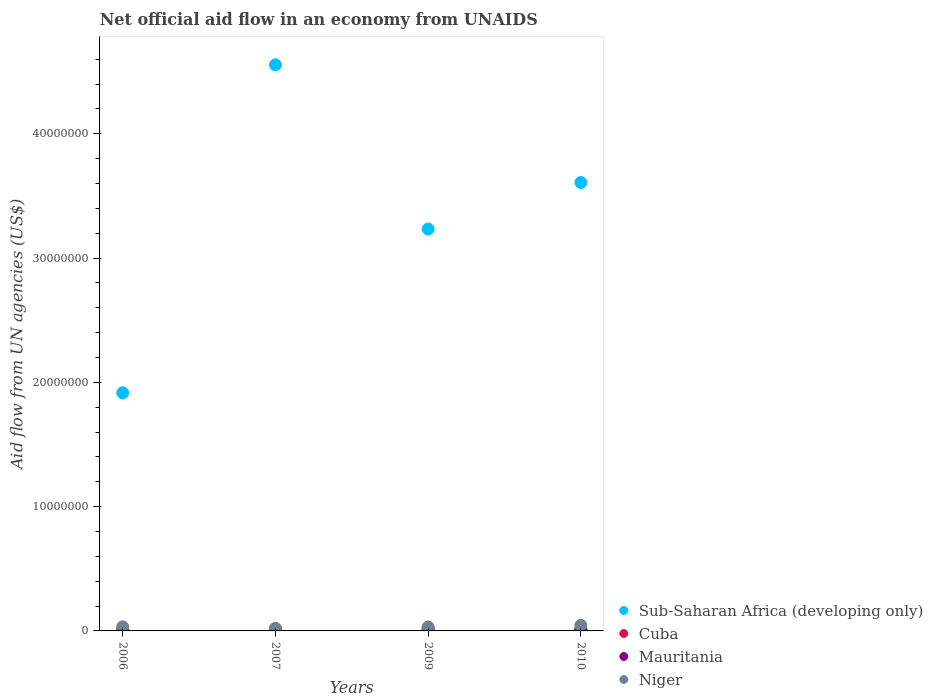How many different coloured dotlines are there?
Your response must be concise. 4. Is the number of dotlines equal to the number of legend labels?
Keep it short and to the point. Yes. What is the net official aid flow in Niger in 2009?
Make the answer very short. 3.20e+05. Across all years, what is the maximum net official aid flow in Sub-Saharan Africa (developing only)?
Provide a succinct answer. 4.56e+07. Across all years, what is the minimum net official aid flow in Mauritania?
Ensure brevity in your answer.  6.00e+04. In which year was the net official aid flow in Sub-Saharan Africa (developing only) minimum?
Give a very brief answer. 2006. What is the total net official aid flow in Mauritania in the graph?
Keep it short and to the point. 5.90e+05. What is the difference between the net official aid flow in Niger in 2007 and that in 2010?
Give a very brief answer. -2.60e+05. What is the difference between the net official aid flow in Mauritania in 2006 and the net official aid flow in Niger in 2010?
Provide a succinct answer. -3.90e+05. What is the average net official aid flow in Mauritania per year?
Keep it short and to the point. 1.48e+05. In the year 2006, what is the difference between the net official aid flow in Sub-Saharan Africa (developing only) and net official aid flow in Mauritania?
Your answer should be very brief. 1.91e+07. In how many years, is the net official aid flow in Cuba greater than 4000000 US$?
Offer a terse response. 0. What is the ratio of the net official aid flow in Sub-Saharan Africa (developing only) in 2006 to that in 2010?
Give a very brief answer. 0.53. Is the sum of the net official aid flow in Niger in 2009 and 2010 greater than the maximum net official aid flow in Cuba across all years?
Keep it short and to the point. Yes. Is it the case that in every year, the sum of the net official aid flow in Cuba and net official aid flow in Niger  is greater than the sum of net official aid flow in Mauritania and net official aid flow in Sub-Saharan Africa (developing only)?
Give a very brief answer. Yes. Is it the case that in every year, the sum of the net official aid flow in Mauritania and net official aid flow in Niger  is greater than the net official aid flow in Cuba?
Provide a short and direct response. Yes. Does the net official aid flow in Niger monotonically increase over the years?
Keep it short and to the point. No. Is the net official aid flow in Mauritania strictly greater than the net official aid flow in Niger over the years?
Provide a short and direct response. No. How many dotlines are there?
Your answer should be very brief. 4. Does the graph contain any zero values?
Your response must be concise. No. Where does the legend appear in the graph?
Give a very brief answer. Bottom right. How are the legend labels stacked?
Provide a succinct answer. Vertical. What is the title of the graph?
Give a very brief answer. Net official aid flow in an economy from UNAIDS. Does "Timor-Leste" appear as one of the legend labels in the graph?
Your answer should be very brief. No. What is the label or title of the X-axis?
Offer a very short reply. Years. What is the label or title of the Y-axis?
Provide a short and direct response. Aid flow from UN agencies (US$). What is the Aid flow from UN agencies (US$) in Sub-Saharan Africa (developing only) in 2006?
Offer a very short reply. 1.92e+07. What is the Aid flow from UN agencies (US$) in Mauritania in 2006?
Your answer should be very brief. 6.00e+04. What is the Aid flow from UN agencies (US$) of Sub-Saharan Africa (developing only) in 2007?
Ensure brevity in your answer.  4.56e+07. What is the Aid flow from UN agencies (US$) in Cuba in 2007?
Give a very brief answer. 1.60e+05. What is the Aid flow from UN agencies (US$) of Mauritania in 2007?
Your response must be concise. 1.90e+05. What is the Aid flow from UN agencies (US$) of Sub-Saharan Africa (developing only) in 2009?
Offer a very short reply. 3.23e+07. What is the Aid flow from UN agencies (US$) in Mauritania in 2009?
Keep it short and to the point. 2.10e+05. What is the Aid flow from UN agencies (US$) in Sub-Saharan Africa (developing only) in 2010?
Offer a terse response. 3.61e+07. What is the Aid flow from UN agencies (US$) of Cuba in 2010?
Your response must be concise. 1.00e+05. Across all years, what is the maximum Aid flow from UN agencies (US$) of Sub-Saharan Africa (developing only)?
Your response must be concise. 4.56e+07. Across all years, what is the maximum Aid flow from UN agencies (US$) of Mauritania?
Make the answer very short. 2.10e+05. Across all years, what is the maximum Aid flow from UN agencies (US$) of Niger?
Your response must be concise. 4.50e+05. Across all years, what is the minimum Aid flow from UN agencies (US$) in Sub-Saharan Africa (developing only)?
Your answer should be compact. 1.92e+07. Across all years, what is the minimum Aid flow from UN agencies (US$) in Niger?
Offer a very short reply. 1.90e+05. What is the total Aid flow from UN agencies (US$) in Sub-Saharan Africa (developing only) in the graph?
Give a very brief answer. 1.33e+08. What is the total Aid flow from UN agencies (US$) of Mauritania in the graph?
Keep it short and to the point. 5.90e+05. What is the total Aid flow from UN agencies (US$) of Niger in the graph?
Provide a succinct answer. 1.29e+06. What is the difference between the Aid flow from UN agencies (US$) in Sub-Saharan Africa (developing only) in 2006 and that in 2007?
Your answer should be compact. -2.64e+07. What is the difference between the Aid flow from UN agencies (US$) of Cuba in 2006 and that in 2007?
Your response must be concise. -5.00e+04. What is the difference between the Aid flow from UN agencies (US$) in Sub-Saharan Africa (developing only) in 2006 and that in 2009?
Provide a succinct answer. -1.32e+07. What is the difference between the Aid flow from UN agencies (US$) in Niger in 2006 and that in 2009?
Your answer should be compact. 10000. What is the difference between the Aid flow from UN agencies (US$) in Sub-Saharan Africa (developing only) in 2006 and that in 2010?
Give a very brief answer. -1.69e+07. What is the difference between the Aid flow from UN agencies (US$) of Niger in 2006 and that in 2010?
Make the answer very short. -1.20e+05. What is the difference between the Aid flow from UN agencies (US$) in Sub-Saharan Africa (developing only) in 2007 and that in 2009?
Your answer should be compact. 1.32e+07. What is the difference between the Aid flow from UN agencies (US$) in Cuba in 2007 and that in 2009?
Provide a succinct answer. 6.00e+04. What is the difference between the Aid flow from UN agencies (US$) of Mauritania in 2007 and that in 2009?
Your response must be concise. -2.00e+04. What is the difference between the Aid flow from UN agencies (US$) of Niger in 2007 and that in 2009?
Give a very brief answer. -1.30e+05. What is the difference between the Aid flow from UN agencies (US$) of Sub-Saharan Africa (developing only) in 2007 and that in 2010?
Your answer should be very brief. 9.47e+06. What is the difference between the Aid flow from UN agencies (US$) of Cuba in 2007 and that in 2010?
Your answer should be very brief. 6.00e+04. What is the difference between the Aid flow from UN agencies (US$) of Sub-Saharan Africa (developing only) in 2009 and that in 2010?
Provide a succinct answer. -3.74e+06. What is the difference between the Aid flow from UN agencies (US$) of Niger in 2009 and that in 2010?
Ensure brevity in your answer.  -1.30e+05. What is the difference between the Aid flow from UN agencies (US$) in Sub-Saharan Africa (developing only) in 2006 and the Aid flow from UN agencies (US$) in Cuba in 2007?
Keep it short and to the point. 1.90e+07. What is the difference between the Aid flow from UN agencies (US$) of Sub-Saharan Africa (developing only) in 2006 and the Aid flow from UN agencies (US$) of Mauritania in 2007?
Your answer should be very brief. 1.90e+07. What is the difference between the Aid flow from UN agencies (US$) in Sub-Saharan Africa (developing only) in 2006 and the Aid flow from UN agencies (US$) in Niger in 2007?
Your answer should be compact. 1.90e+07. What is the difference between the Aid flow from UN agencies (US$) of Cuba in 2006 and the Aid flow from UN agencies (US$) of Niger in 2007?
Your answer should be compact. -8.00e+04. What is the difference between the Aid flow from UN agencies (US$) in Sub-Saharan Africa (developing only) in 2006 and the Aid flow from UN agencies (US$) in Cuba in 2009?
Your response must be concise. 1.91e+07. What is the difference between the Aid flow from UN agencies (US$) of Sub-Saharan Africa (developing only) in 2006 and the Aid flow from UN agencies (US$) of Mauritania in 2009?
Keep it short and to the point. 1.90e+07. What is the difference between the Aid flow from UN agencies (US$) in Sub-Saharan Africa (developing only) in 2006 and the Aid flow from UN agencies (US$) in Niger in 2009?
Offer a very short reply. 1.88e+07. What is the difference between the Aid flow from UN agencies (US$) of Mauritania in 2006 and the Aid flow from UN agencies (US$) of Niger in 2009?
Offer a very short reply. -2.60e+05. What is the difference between the Aid flow from UN agencies (US$) in Sub-Saharan Africa (developing only) in 2006 and the Aid flow from UN agencies (US$) in Cuba in 2010?
Give a very brief answer. 1.91e+07. What is the difference between the Aid flow from UN agencies (US$) in Sub-Saharan Africa (developing only) in 2006 and the Aid flow from UN agencies (US$) in Mauritania in 2010?
Offer a terse response. 1.90e+07. What is the difference between the Aid flow from UN agencies (US$) of Sub-Saharan Africa (developing only) in 2006 and the Aid flow from UN agencies (US$) of Niger in 2010?
Provide a succinct answer. 1.87e+07. What is the difference between the Aid flow from UN agencies (US$) of Cuba in 2006 and the Aid flow from UN agencies (US$) of Mauritania in 2010?
Ensure brevity in your answer.  -2.00e+04. What is the difference between the Aid flow from UN agencies (US$) in Cuba in 2006 and the Aid flow from UN agencies (US$) in Niger in 2010?
Offer a terse response. -3.40e+05. What is the difference between the Aid flow from UN agencies (US$) of Mauritania in 2006 and the Aid flow from UN agencies (US$) of Niger in 2010?
Offer a very short reply. -3.90e+05. What is the difference between the Aid flow from UN agencies (US$) of Sub-Saharan Africa (developing only) in 2007 and the Aid flow from UN agencies (US$) of Cuba in 2009?
Your answer should be compact. 4.54e+07. What is the difference between the Aid flow from UN agencies (US$) of Sub-Saharan Africa (developing only) in 2007 and the Aid flow from UN agencies (US$) of Mauritania in 2009?
Make the answer very short. 4.53e+07. What is the difference between the Aid flow from UN agencies (US$) in Sub-Saharan Africa (developing only) in 2007 and the Aid flow from UN agencies (US$) in Niger in 2009?
Your answer should be very brief. 4.52e+07. What is the difference between the Aid flow from UN agencies (US$) of Cuba in 2007 and the Aid flow from UN agencies (US$) of Mauritania in 2009?
Offer a terse response. -5.00e+04. What is the difference between the Aid flow from UN agencies (US$) in Cuba in 2007 and the Aid flow from UN agencies (US$) in Niger in 2009?
Give a very brief answer. -1.60e+05. What is the difference between the Aid flow from UN agencies (US$) in Sub-Saharan Africa (developing only) in 2007 and the Aid flow from UN agencies (US$) in Cuba in 2010?
Provide a succinct answer. 4.54e+07. What is the difference between the Aid flow from UN agencies (US$) of Sub-Saharan Africa (developing only) in 2007 and the Aid flow from UN agencies (US$) of Mauritania in 2010?
Ensure brevity in your answer.  4.54e+07. What is the difference between the Aid flow from UN agencies (US$) of Sub-Saharan Africa (developing only) in 2007 and the Aid flow from UN agencies (US$) of Niger in 2010?
Provide a short and direct response. 4.51e+07. What is the difference between the Aid flow from UN agencies (US$) in Cuba in 2007 and the Aid flow from UN agencies (US$) in Niger in 2010?
Give a very brief answer. -2.90e+05. What is the difference between the Aid flow from UN agencies (US$) in Mauritania in 2007 and the Aid flow from UN agencies (US$) in Niger in 2010?
Your response must be concise. -2.60e+05. What is the difference between the Aid flow from UN agencies (US$) of Sub-Saharan Africa (developing only) in 2009 and the Aid flow from UN agencies (US$) of Cuba in 2010?
Keep it short and to the point. 3.22e+07. What is the difference between the Aid flow from UN agencies (US$) in Sub-Saharan Africa (developing only) in 2009 and the Aid flow from UN agencies (US$) in Mauritania in 2010?
Your answer should be compact. 3.22e+07. What is the difference between the Aid flow from UN agencies (US$) of Sub-Saharan Africa (developing only) in 2009 and the Aid flow from UN agencies (US$) of Niger in 2010?
Your answer should be compact. 3.19e+07. What is the difference between the Aid flow from UN agencies (US$) in Cuba in 2009 and the Aid flow from UN agencies (US$) in Niger in 2010?
Your answer should be compact. -3.50e+05. What is the average Aid flow from UN agencies (US$) of Sub-Saharan Africa (developing only) per year?
Ensure brevity in your answer.  3.33e+07. What is the average Aid flow from UN agencies (US$) in Cuba per year?
Provide a succinct answer. 1.18e+05. What is the average Aid flow from UN agencies (US$) in Mauritania per year?
Ensure brevity in your answer.  1.48e+05. What is the average Aid flow from UN agencies (US$) of Niger per year?
Give a very brief answer. 3.22e+05. In the year 2006, what is the difference between the Aid flow from UN agencies (US$) of Sub-Saharan Africa (developing only) and Aid flow from UN agencies (US$) of Cuba?
Give a very brief answer. 1.90e+07. In the year 2006, what is the difference between the Aid flow from UN agencies (US$) of Sub-Saharan Africa (developing only) and Aid flow from UN agencies (US$) of Mauritania?
Ensure brevity in your answer.  1.91e+07. In the year 2006, what is the difference between the Aid flow from UN agencies (US$) of Sub-Saharan Africa (developing only) and Aid flow from UN agencies (US$) of Niger?
Give a very brief answer. 1.88e+07. In the year 2006, what is the difference between the Aid flow from UN agencies (US$) of Cuba and Aid flow from UN agencies (US$) of Niger?
Keep it short and to the point. -2.20e+05. In the year 2006, what is the difference between the Aid flow from UN agencies (US$) of Mauritania and Aid flow from UN agencies (US$) of Niger?
Give a very brief answer. -2.70e+05. In the year 2007, what is the difference between the Aid flow from UN agencies (US$) of Sub-Saharan Africa (developing only) and Aid flow from UN agencies (US$) of Cuba?
Provide a succinct answer. 4.54e+07. In the year 2007, what is the difference between the Aid flow from UN agencies (US$) in Sub-Saharan Africa (developing only) and Aid flow from UN agencies (US$) in Mauritania?
Offer a very short reply. 4.54e+07. In the year 2007, what is the difference between the Aid flow from UN agencies (US$) in Sub-Saharan Africa (developing only) and Aid flow from UN agencies (US$) in Niger?
Keep it short and to the point. 4.54e+07. In the year 2009, what is the difference between the Aid flow from UN agencies (US$) in Sub-Saharan Africa (developing only) and Aid flow from UN agencies (US$) in Cuba?
Your answer should be very brief. 3.22e+07. In the year 2009, what is the difference between the Aid flow from UN agencies (US$) in Sub-Saharan Africa (developing only) and Aid flow from UN agencies (US$) in Mauritania?
Your answer should be very brief. 3.21e+07. In the year 2009, what is the difference between the Aid flow from UN agencies (US$) of Sub-Saharan Africa (developing only) and Aid flow from UN agencies (US$) of Niger?
Offer a very short reply. 3.20e+07. In the year 2009, what is the difference between the Aid flow from UN agencies (US$) in Cuba and Aid flow from UN agencies (US$) in Mauritania?
Provide a short and direct response. -1.10e+05. In the year 2009, what is the difference between the Aid flow from UN agencies (US$) in Cuba and Aid flow from UN agencies (US$) in Niger?
Provide a succinct answer. -2.20e+05. In the year 2009, what is the difference between the Aid flow from UN agencies (US$) of Mauritania and Aid flow from UN agencies (US$) of Niger?
Keep it short and to the point. -1.10e+05. In the year 2010, what is the difference between the Aid flow from UN agencies (US$) in Sub-Saharan Africa (developing only) and Aid flow from UN agencies (US$) in Cuba?
Your answer should be compact. 3.60e+07. In the year 2010, what is the difference between the Aid flow from UN agencies (US$) of Sub-Saharan Africa (developing only) and Aid flow from UN agencies (US$) of Mauritania?
Provide a succinct answer. 3.60e+07. In the year 2010, what is the difference between the Aid flow from UN agencies (US$) of Sub-Saharan Africa (developing only) and Aid flow from UN agencies (US$) of Niger?
Ensure brevity in your answer.  3.56e+07. In the year 2010, what is the difference between the Aid flow from UN agencies (US$) of Cuba and Aid flow from UN agencies (US$) of Niger?
Offer a terse response. -3.50e+05. In the year 2010, what is the difference between the Aid flow from UN agencies (US$) of Mauritania and Aid flow from UN agencies (US$) of Niger?
Provide a short and direct response. -3.20e+05. What is the ratio of the Aid flow from UN agencies (US$) of Sub-Saharan Africa (developing only) in 2006 to that in 2007?
Offer a very short reply. 0.42. What is the ratio of the Aid flow from UN agencies (US$) of Cuba in 2006 to that in 2007?
Your response must be concise. 0.69. What is the ratio of the Aid flow from UN agencies (US$) of Mauritania in 2006 to that in 2007?
Offer a terse response. 0.32. What is the ratio of the Aid flow from UN agencies (US$) in Niger in 2006 to that in 2007?
Provide a short and direct response. 1.74. What is the ratio of the Aid flow from UN agencies (US$) of Sub-Saharan Africa (developing only) in 2006 to that in 2009?
Provide a short and direct response. 0.59. What is the ratio of the Aid flow from UN agencies (US$) in Cuba in 2006 to that in 2009?
Give a very brief answer. 1.1. What is the ratio of the Aid flow from UN agencies (US$) in Mauritania in 2006 to that in 2009?
Provide a succinct answer. 0.29. What is the ratio of the Aid flow from UN agencies (US$) of Niger in 2006 to that in 2009?
Your response must be concise. 1.03. What is the ratio of the Aid flow from UN agencies (US$) of Sub-Saharan Africa (developing only) in 2006 to that in 2010?
Provide a short and direct response. 0.53. What is the ratio of the Aid flow from UN agencies (US$) of Cuba in 2006 to that in 2010?
Ensure brevity in your answer.  1.1. What is the ratio of the Aid flow from UN agencies (US$) in Mauritania in 2006 to that in 2010?
Your answer should be very brief. 0.46. What is the ratio of the Aid flow from UN agencies (US$) of Niger in 2006 to that in 2010?
Your answer should be very brief. 0.73. What is the ratio of the Aid flow from UN agencies (US$) in Sub-Saharan Africa (developing only) in 2007 to that in 2009?
Make the answer very short. 1.41. What is the ratio of the Aid flow from UN agencies (US$) of Cuba in 2007 to that in 2009?
Your answer should be compact. 1.6. What is the ratio of the Aid flow from UN agencies (US$) in Mauritania in 2007 to that in 2009?
Provide a succinct answer. 0.9. What is the ratio of the Aid flow from UN agencies (US$) in Niger in 2007 to that in 2009?
Your answer should be compact. 0.59. What is the ratio of the Aid flow from UN agencies (US$) in Sub-Saharan Africa (developing only) in 2007 to that in 2010?
Offer a very short reply. 1.26. What is the ratio of the Aid flow from UN agencies (US$) in Cuba in 2007 to that in 2010?
Ensure brevity in your answer.  1.6. What is the ratio of the Aid flow from UN agencies (US$) in Mauritania in 2007 to that in 2010?
Keep it short and to the point. 1.46. What is the ratio of the Aid flow from UN agencies (US$) in Niger in 2007 to that in 2010?
Offer a very short reply. 0.42. What is the ratio of the Aid flow from UN agencies (US$) in Sub-Saharan Africa (developing only) in 2009 to that in 2010?
Make the answer very short. 0.9. What is the ratio of the Aid flow from UN agencies (US$) in Mauritania in 2009 to that in 2010?
Your answer should be compact. 1.62. What is the ratio of the Aid flow from UN agencies (US$) in Niger in 2009 to that in 2010?
Offer a very short reply. 0.71. What is the difference between the highest and the second highest Aid flow from UN agencies (US$) in Sub-Saharan Africa (developing only)?
Make the answer very short. 9.47e+06. What is the difference between the highest and the second highest Aid flow from UN agencies (US$) of Cuba?
Offer a terse response. 5.00e+04. What is the difference between the highest and the lowest Aid flow from UN agencies (US$) of Sub-Saharan Africa (developing only)?
Provide a short and direct response. 2.64e+07. What is the difference between the highest and the lowest Aid flow from UN agencies (US$) of Mauritania?
Your answer should be very brief. 1.50e+05. 